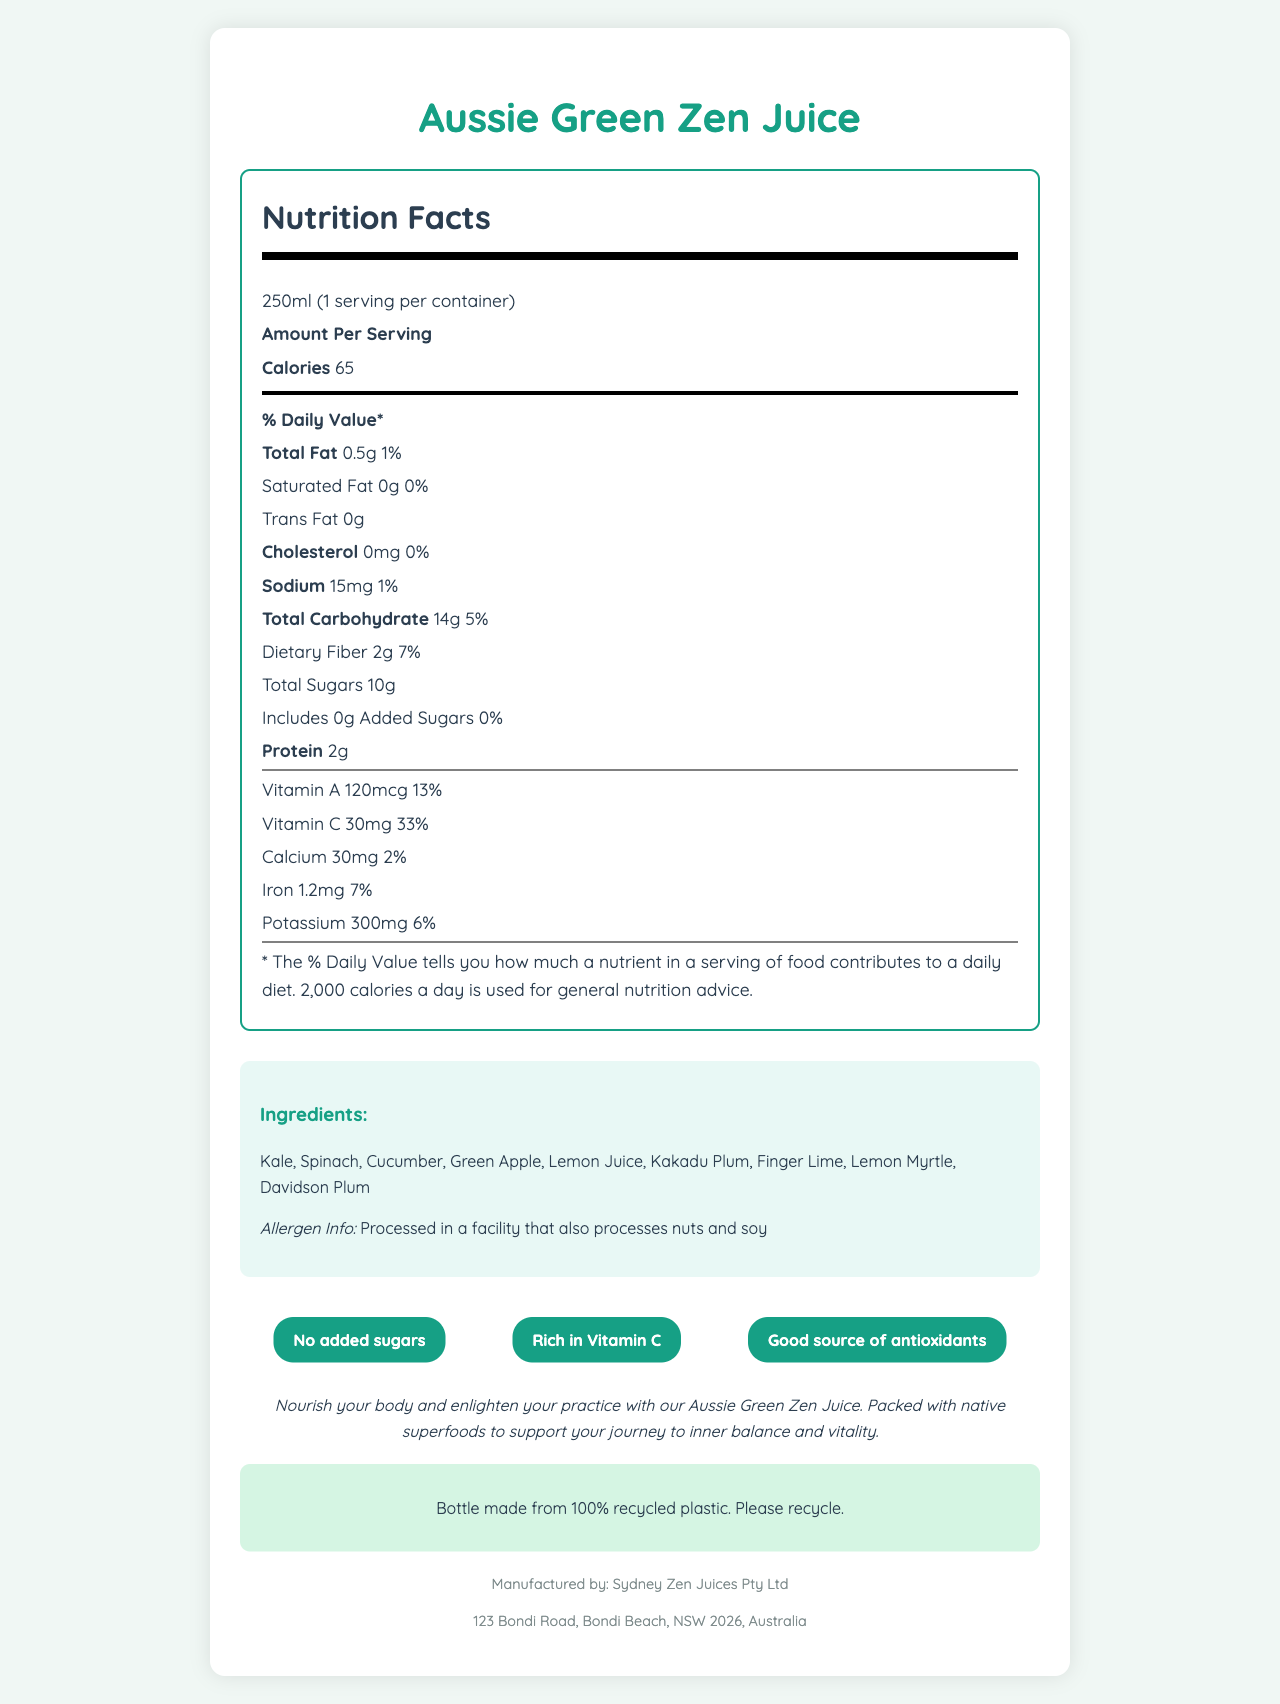what is the serving size of the Aussie Green Zen Juice? The document states that the serving size is 250ml.
Answer: 250ml how many calories are there per serving? The document indicates that there are 65 calories per serving.
Answer: 65 what is the total amount of fat in the juice? The total amount of fat in the juice is listed as 0.5g on the document.
Answer: 0.5g does the juice contain any added sugars? The document specifies that there are 0g of added sugars in the juice.
Answer: No what is the percentage daily value of vitamin C in the juice? The document shows that the juice provides 33% of the daily value for vitamin C.
Answer: 33% which of the following ingredients is not in the Aussie Green Zen Juice? A. Kale B. Spinach C. Banana D. Lemon Myrtle Banana is not listed among the ingredients; instead, Kale, Spinach, and Lemon Myrtle are mentioned.
Answer: C how much sodium does the juice contain? A. 20mg B. 15mg C. 10mg D. 5mg The document states that the juice contains 15mg of sodium.
Answer: B is the juice a good source of antioxidants? According to the nutritional claims on the document, the juice is a good source of antioxidants.
Answer: Yes how much protein is in one serving? The label indicates that there are 2g of protein in each serving.
Answer: 2g does this product contain dietary fiber, and if so, how much? The document lists that the juice contains 2g of dietary fiber per serving.
Answer: Yes, 2g summarize the main features of the Aussie Green Zen Juice. This summary encapsulates the key features, nutritional benefits, ingredients, sustainability note, and general health claims of the Aussie Green Zen Juice as presented in the document.
Answer: The Aussie Green Zen Juice is a cold-pressed green juice featuring native Australian ingredients like Kakadu Plum, Finger Lime, and Davidson Plum. Each 250ml serving contains 65 calories, 0.5g of total fat, 14g of carbohydrates (including 2g of dietary fiber and 10g of sugars), and 2g of protein. It has notable amounts of vitamin C (33% DV) and vitamin A (13% DV) and is free from added sugars. The product's allergen info states it is processed in a facility that also handles nuts and soy. The juice claims to be rich in vitamin C, a good source of antioxidants, and has a yoga-inspired description focusing on inner balance and vitality. Additionally, the bottle is made from 100% recycled plastic. who is the manufacturer of the Aussie Green Zen Juice? The manufacturer is listed as Sydney Zen Juices Pty Ltd in the document.
Answer: Sydney Zen Juices Pty Ltd are there any allergens in the juice? The document states that it is processed in a facility that also processes nuts and soy.
Answer: Not directly, but the juice is processed in a facility that also processes nuts and soy what is the address of the manufacturer? The address provided in the document is 123 Bondi Road, Bondi Beach, NSW 2026, Australia.
Answer: 123 Bondi Road, Bondi Beach, NSW 2026, Australia what flavor of plums are included in the ingredients? The document lists both Davidson Plum and Kakadu Plum as ingredients in the juice.
Answer: Davidson Plum, Kakadu Plum what percentage of the daily value of calcium does the juice provide? According to the document, the juice provides 2% of the daily value for calcium.
Answer: 2% what is the source of the calories in the juice? The exact sources of calories (whether from sugar, fat, or protein) are not explicitly broken down in the document beyond the given macronutrient information.
Answer: Cannot be determined what sustainability claim is made about the packaging? The document states that the bottle is made from 100% recycled plastic and encourages recycling.
Answer: The bottle is made from 100% recycled plastic 